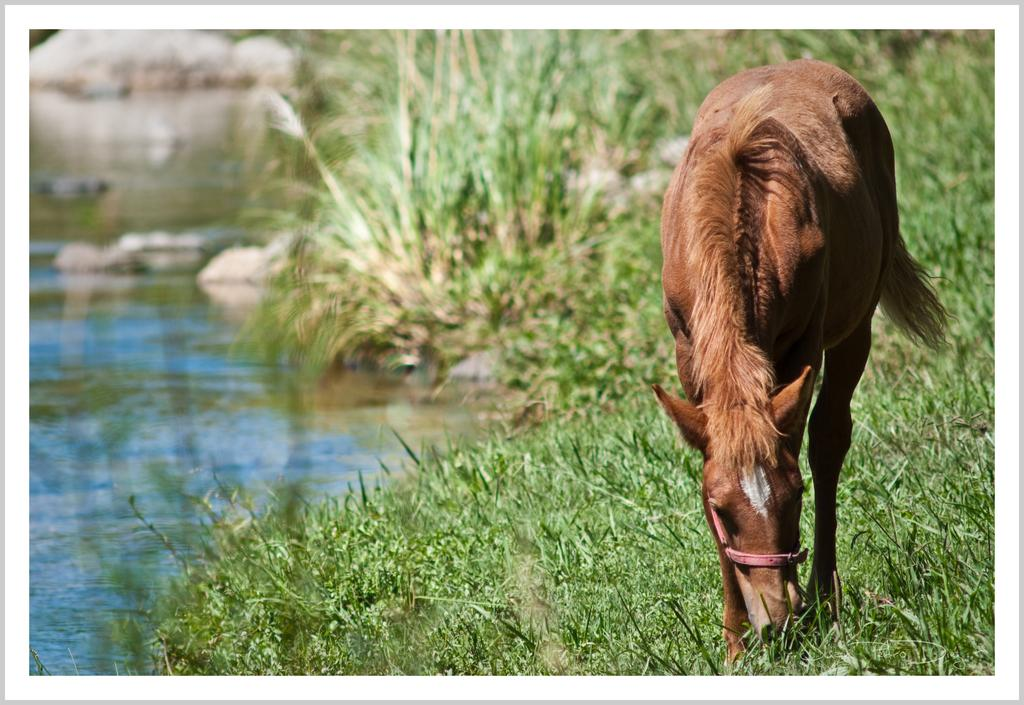What is the main subject in the foreground of the image? There is a horse in the foreground of the image. What type of terrain is visible at the bottom of the image? There is grass and a river at the bottom of the image. What can be seen in the background of the image? There are plants and rocks in the background of the image. How does the horse interact with the snow in the image? There is no snow present in the image. 